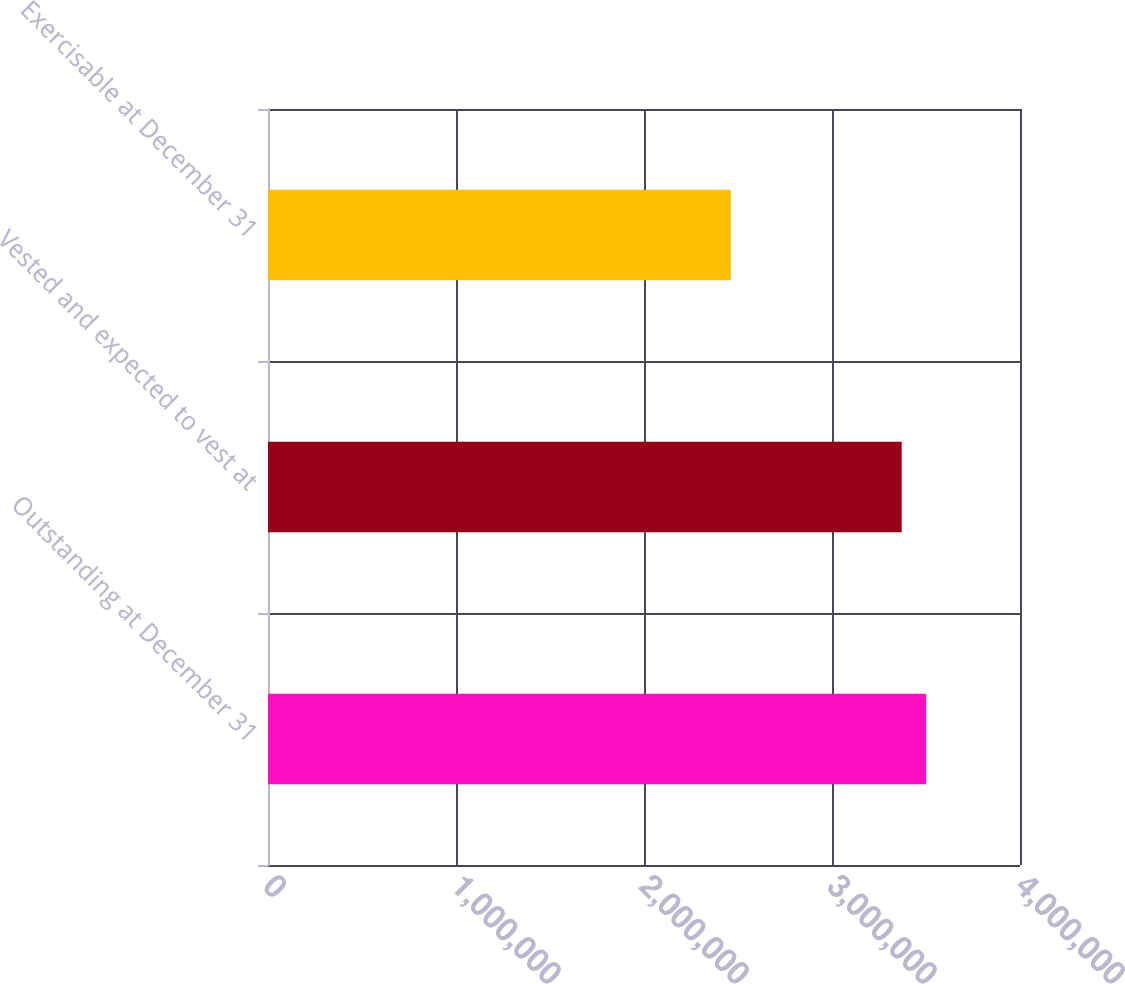<chart> <loc_0><loc_0><loc_500><loc_500><bar_chart><fcel>Outstanding at December 31<fcel>Vested and expected to vest at<fcel>Exercisable at December 31<nl><fcel>3.50072e+06<fcel>3.37082e+06<fcel>2.46165e+06<nl></chart> 